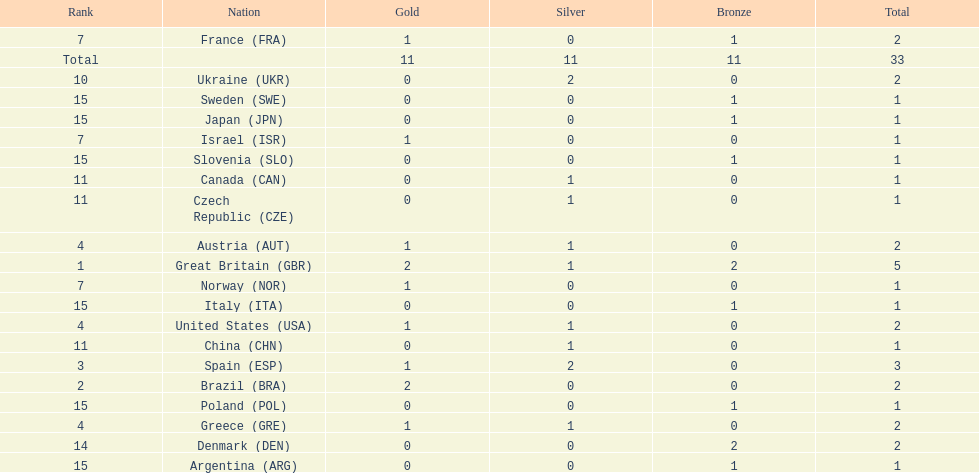What was the total number of medals won by united states? 2. 